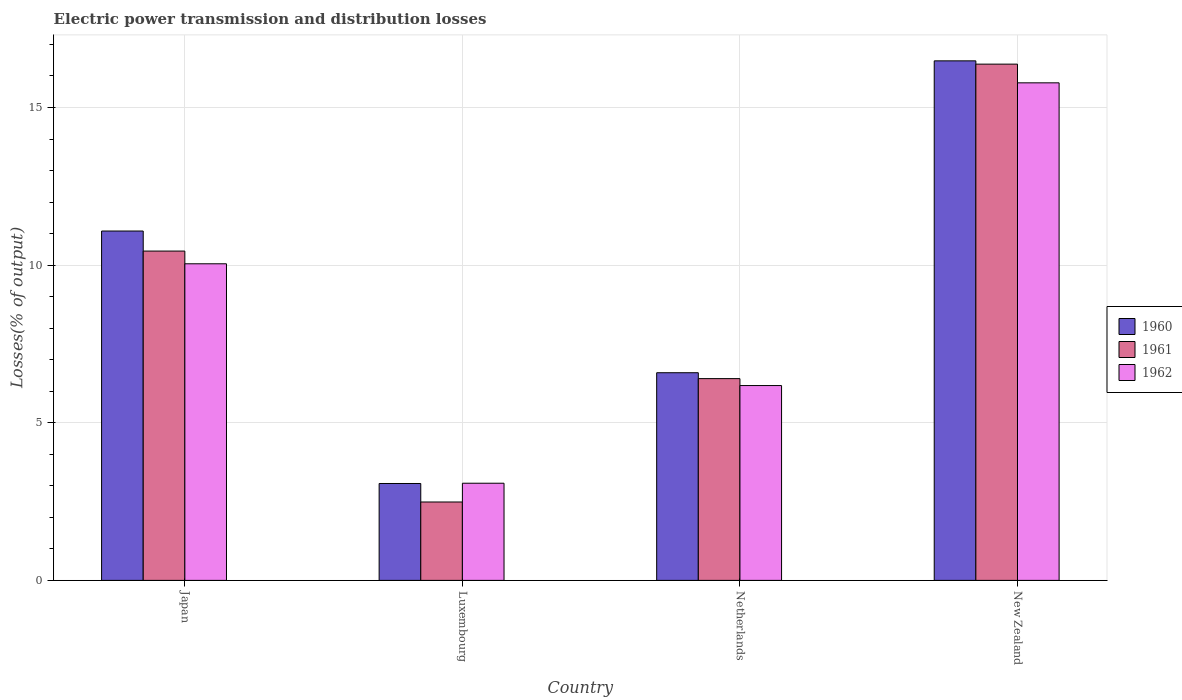How many different coloured bars are there?
Your answer should be compact. 3. How many groups of bars are there?
Provide a short and direct response. 4. Are the number of bars on each tick of the X-axis equal?
Offer a very short reply. Yes. What is the label of the 1st group of bars from the left?
Ensure brevity in your answer.  Japan. What is the electric power transmission and distribution losses in 1960 in Japan?
Ensure brevity in your answer.  11.08. Across all countries, what is the maximum electric power transmission and distribution losses in 1961?
Keep it short and to the point. 16.38. Across all countries, what is the minimum electric power transmission and distribution losses in 1960?
Keep it short and to the point. 3.07. In which country was the electric power transmission and distribution losses in 1962 maximum?
Your answer should be compact. New Zealand. In which country was the electric power transmission and distribution losses in 1962 minimum?
Give a very brief answer. Luxembourg. What is the total electric power transmission and distribution losses in 1962 in the graph?
Provide a short and direct response. 35.09. What is the difference between the electric power transmission and distribution losses in 1960 in Japan and that in Netherlands?
Offer a very short reply. 4.49. What is the difference between the electric power transmission and distribution losses in 1960 in Japan and the electric power transmission and distribution losses in 1961 in New Zealand?
Your answer should be very brief. -5.29. What is the average electric power transmission and distribution losses in 1960 per country?
Your response must be concise. 9.31. What is the difference between the electric power transmission and distribution losses of/in 1962 and electric power transmission and distribution losses of/in 1960 in New Zealand?
Ensure brevity in your answer.  -0.7. What is the ratio of the electric power transmission and distribution losses in 1962 in Japan to that in Luxembourg?
Your answer should be very brief. 3.26. Is the difference between the electric power transmission and distribution losses in 1962 in Japan and New Zealand greater than the difference between the electric power transmission and distribution losses in 1960 in Japan and New Zealand?
Ensure brevity in your answer.  No. What is the difference between the highest and the second highest electric power transmission and distribution losses in 1962?
Your answer should be compact. 3.86. What is the difference between the highest and the lowest electric power transmission and distribution losses in 1961?
Offer a terse response. 13.89. In how many countries, is the electric power transmission and distribution losses in 1960 greater than the average electric power transmission and distribution losses in 1960 taken over all countries?
Your answer should be very brief. 2. Is it the case that in every country, the sum of the electric power transmission and distribution losses in 1960 and electric power transmission and distribution losses in 1961 is greater than the electric power transmission and distribution losses in 1962?
Ensure brevity in your answer.  Yes. How many countries are there in the graph?
Your response must be concise. 4. Are the values on the major ticks of Y-axis written in scientific E-notation?
Keep it short and to the point. No. How many legend labels are there?
Offer a very short reply. 3. How are the legend labels stacked?
Make the answer very short. Vertical. What is the title of the graph?
Your answer should be compact. Electric power transmission and distribution losses. Does "1999" appear as one of the legend labels in the graph?
Offer a very short reply. No. What is the label or title of the X-axis?
Your answer should be compact. Country. What is the label or title of the Y-axis?
Your answer should be compact. Losses(% of output). What is the Losses(% of output) in 1960 in Japan?
Keep it short and to the point. 11.08. What is the Losses(% of output) of 1961 in Japan?
Ensure brevity in your answer.  10.45. What is the Losses(% of output) in 1962 in Japan?
Offer a terse response. 10.04. What is the Losses(% of output) in 1960 in Luxembourg?
Ensure brevity in your answer.  3.07. What is the Losses(% of output) of 1961 in Luxembourg?
Offer a very short reply. 2.49. What is the Losses(% of output) in 1962 in Luxembourg?
Provide a short and direct response. 3.08. What is the Losses(% of output) of 1960 in Netherlands?
Make the answer very short. 6.59. What is the Losses(% of output) in 1961 in Netherlands?
Give a very brief answer. 6.4. What is the Losses(% of output) of 1962 in Netherlands?
Ensure brevity in your answer.  6.18. What is the Losses(% of output) of 1960 in New Zealand?
Your answer should be compact. 16.48. What is the Losses(% of output) of 1961 in New Zealand?
Your answer should be compact. 16.38. What is the Losses(% of output) of 1962 in New Zealand?
Keep it short and to the point. 15.78. Across all countries, what is the maximum Losses(% of output) of 1960?
Your response must be concise. 16.48. Across all countries, what is the maximum Losses(% of output) of 1961?
Provide a succinct answer. 16.38. Across all countries, what is the maximum Losses(% of output) of 1962?
Provide a succinct answer. 15.78. Across all countries, what is the minimum Losses(% of output) of 1960?
Offer a very short reply. 3.07. Across all countries, what is the minimum Losses(% of output) in 1961?
Offer a terse response. 2.49. Across all countries, what is the minimum Losses(% of output) in 1962?
Offer a terse response. 3.08. What is the total Losses(% of output) in 1960 in the graph?
Your answer should be very brief. 37.22. What is the total Losses(% of output) in 1961 in the graph?
Provide a short and direct response. 35.71. What is the total Losses(% of output) of 1962 in the graph?
Offer a very short reply. 35.09. What is the difference between the Losses(% of output) of 1960 in Japan and that in Luxembourg?
Keep it short and to the point. 8.01. What is the difference between the Losses(% of output) of 1961 in Japan and that in Luxembourg?
Keep it short and to the point. 7.96. What is the difference between the Losses(% of output) in 1962 in Japan and that in Luxembourg?
Offer a very short reply. 6.96. What is the difference between the Losses(% of output) of 1960 in Japan and that in Netherlands?
Make the answer very short. 4.49. What is the difference between the Losses(% of output) in 1961 in Japan and that in Netherlands?
Offer a very short reply. 4.05. What is the difference between the Losses(% of output) in 1962 in Japan and that in Netherlands?
Ensure brevity in your answer.  3.86. What is the difference between the Losses(% of output) in 1960 in Japan and that in New Zealand?
Offer a very short reply. -5.4. What is the difference between the Losses(% of output) in 1961 in Japan and that in New Zealand?
Offer a terse response. -5.93. What is the difference between the Losses(% of output) in 1962 in Japan and that in New Zealand?
Your answer should be very brief. -5.74. What is the difference between the Losses(% of output) of 1960 in Luxembourg and that in Netherlands?
Provide a short and direct response. -3.51. What is the difference between the Losses(% of output) of 1961 in Luxembourg and that in Netherlands?
Provide a succinct answer. -3.91. What is the difference between the Losses(% of output) of 1962 in Luxembourg and that in Netherlands?
Provide a succinct answer. -3.1. What is the difference between the Losses(% of output) in 1960 in Luxembourg and that in New Zealand?
Your response must be concise. -13.41. What is the difference between the Losses(% of output) of 1961 in Luxembourg and that in New Zealand?
Your answer should be very brief. -13.89. What is the difference between the Losses(% of output) of 1962 in Luxembourg and that in New Zealand?
Make the answer very short. -12.7. What is the difference between the Losses(% of output) in 1960 in Netherlands and that in New Zealand?
Make the answer very short. -9.89. What is the difference between the Losses(% of output) in 1961 in Netherlands and that in New Zealand?
Make the answer very short. -9.98. What is the difference between the Losses(% of output) in 1962 in Netherlands and that in New Zealand?
Your answer should be very brief. -9.6. What is the difference between the Losses(% of output) in 1960 in Japan and the Losses(% of output) in 1961 in Luxembourg?
Provide a short and direct response. 8.6. What is the difference between the Losses(% of output) in 1960 in Japan and the Losses(% of output) in 1962 in Luxembourg?
Offer a terse response. 8. What is the difference between the Losses(% of output) of 1961 in Japan and the Losses(% of output) of 1962 in Luxembourg?
Provide a succinct answer. 7.36. What is the difference between the Losses(% of output) in 1960 in Japan and the Losses(% of output) in 1961 in Netherlands?
Your answer should be very brief. 4.68. What is the difference between the Losses(% of output) of 1960 in Japan and the Losses(% of output) of 1962 in Netherlands?
Provide a succinct answer. 4.9. What is the difference between the Losses(% of output) in 1961 in Japan and the Losses(% of output) in 1962 in Netherlands?
Make the answer very short. 4.27. What is the difference between the Losses(% of output) in 1960 in Japan and the Losses(% of output) in 1961 in New Zealand?
Your answer should be very brief. -5.29. What is the difference between the Losses(% of output) in 1960 in Japan and the Losses(% of output) in 1962 in New Zealand?
Give a very brief answer. -4.7. What is the difference between the Losses(% of output) of 1961 in Japan and the Losses(% of output) of 1962 in New Zealand?
Your response must be concise. -5.34. What is the difference between the Losses(% of output) of 1960 in Luxembourg and the Losses(% of output) of 1961 in Netherlands?
Offer a very short reply. -3.33. What is the difference between the Losses(% of output) of 1960 in Luxembourg and the Losses(% of output) of 1962 in Netherlands?
Your answer should be compact. -3.11. What is the difference between the Losses(% of output) of 1961 in Luxembourg and the Losses(% of output) of 1962 in Netherlands?
Keep it short and to the point. -3.69. What is the difference between the Losses(% of output) of 1960 in Luxembourg and the Losses(% of output) of 1961 in New Zealand?
Provide a short and direct response. -13.3. What is the difference between the Losses(% of output) of 1960 in Luxembourg and the Losses(% of output) of 1962 in New Zealand?
Your answer should be very brief. -12.71. What is the difference between the Losses(% of output) of 1961 in Luxembourg and the Losses(% of output) of 1962 in New Zealand?
Your response must be concise. -13.3. What is the difference between the Losses(% of output) in 1960 in Netherlands and the Losses(% of output) in 1961 in New Zealand?
Offer a very short reply. -9.79. What is the difference between the Losses(% of output) of 1960 in Netherlands and the Losses(% of output) of 1962 in New Zealand?
Offer a terse response. -9.2. What is the difference between the Losses(% of output) of 1961 in Netherlands and the Losses(% of output) of 1962 in New Zealand?
Your response must be concise. -9.38. What is the average Losses(% of output) in 1960 per country?
Provide a short and direct response. 9.31. What is the average Losses(% of output) in 1961 per country?
Give a very brief answer. 8.93. What is the average Losses(% of output) in 1962 per country?
Your response must be concise. 8.77. What is the difference between the Losses(% of output) in 1960 and Losses(% of output) in 1961 in Japan?
Offer a terse response. 0.64. What is the difference between the Losses(% of output) in 1960 and Losses(% of output) in 1962 in Japan?
Offer a very short reply. 1.04. What is the difference between the Losses(% of output) of 1961 and Losses(% of output) of 1962 in Japan?
Provide a succinct answer. 0.4. What is the difference between the Losses(% of output) in 1960 and Losses(% of output) in 1961 in Luxembourg?
Make the answer very short. 0.59. What is the difference between the Losses(% of output) of 1960 and Losses(% of output) of 1962 in Luxembourg?
Offer a terse response. -0.01. What is the difference between the Losses(% of output) in 1961 and Losses(% of output) in 1962 in Luxembourg?
Your answer should be very brief. -0.6. What is the difference between the Losses(% of output) of 1960 and Losses(% of output) of 1961 in Netherlands?
Provide a short and direct response. 0.19. What is the difference between the Losses(% of output) in 1960 and Losses(% of output) in 1962 in Netherlands?
Ensure brevity in your answer.  0.41. What is the difference between the Losses(% of output) of 1961 and Losses(% of output) of 1962 in Netherlands?
Provide a short and direct response. 0.22. What is the difference between the Losses(% of output) of 1960 and Losses(% of output) of 1961 in New Zealand?
Your answer should be compact. 0.1. What is the difference between the Losses(% of output) in 1960 and Losses(% of output) in 1962 in New Zealand?
Give a very brief answer. 0.7. What is the difference between the Losses(% of output) in 1961 and Losses(% of output) in 1962 in New Zealand?
Ensure brevity in your answer.  0.59. What is the ratio of the Losses(% of output) in 1960 in Japan to that in Luxembourg?
Offer a terse response. 3.61. What is the ratio of the Losses(% of output) in 1961 in Japan to that in Luxembourg?
Your response must be concise. 4.2. What is the ratio of the Losses(% of output) in 1962 in Japan to that in Luxembourg?
Ensure brevity in your answer.  3.26. What is the ratio of the Losses(% of output) in 1960 in Japan to that in Netherlands?
Your response must be concise. 1.68. What is the ratio of the Losses(% of output) in 1961 in Japan to that in Netherlands?
Provide a succinct answer. 1.63. What is the ratio of the Losses(% of output) in 1962 in Japan to that in Netherlands?
Your answer should be very brief. 1.62. What is the ratio of the Losses(% of output) of 1960 in Japan to that in New Zealand?
Ensure brevity in your answer.  0.67. What is the ratio of the Losses(% of output) of 1961 in Japan to that in New Zealand?
Your answer should be compact. 0.64. What is the ratio of the Losses(% of output) in 1962 in Japan to that in New Zealand?
Provide a succinct answer. 0.64. What is the ratio of the Losses(% of output) in 1960 in Luxembourg to that in Netherlands?
Your response must be concise. 0.47. What is the ratio of the Losses(% of output) of 1961 in Luxembourg to that in Netherlands?
Provide a succinct answer. 0.39. What is the ratio of the Losses(% of output) of 1962 in Luxembourg to that in Netherlands?
Provide a succinct answer. 0.5. What is the ratio of the Losses(% of output) in 1960 in Luxembourg to that in New Zealand?
Your answer should be compact. 0.19. What is the ratio of the Losses(% of output) of 1961 in Luxembourg to that in New Zealand?
Your answer should be compact. 0.15. What is the ratio of the Losses(% of output) of 1962 in Luxembourg to that in New Zealand?
Your answer should be very brief. 0.2. What is the ratio of the Losses(% of output) in 1960 in Netherlands to that in New Zealand?
Give a very brief answer. 0.4. What is the ratio of the Losses(% of output) in 1961 in Netherlands to that in New Zealand?
Keep it short and to the point. 0.39. What is the ratio of the Losses(% of output) of 1962 in Netherlands to that in New Zealand?
Provide a succinct answer. 0.39. What is the difference between the highest and the second highest Losses(% of output) of 1960?
Provide a short and direct response. 5.4. What is the difference between the highest and the second highest Losses(% of output) in 1961?
Keep it short and to the point. 5.93. What is the difference between the highest and the second highest Losses(% of output) of 1962?
Give a very brief answer. 5.74. What is the difference between the highest and the lowest Losses(% of output) in 1960?
Ensure brevity in your answer.  13.41. What is the difference between the highest and the lowest Losses(% of output) of 1961?
Your response must be concise. 13.89. What is the difference between the highest and the lowest Losses(% of output) in 1962?
Your response must be concise. 12.7. 